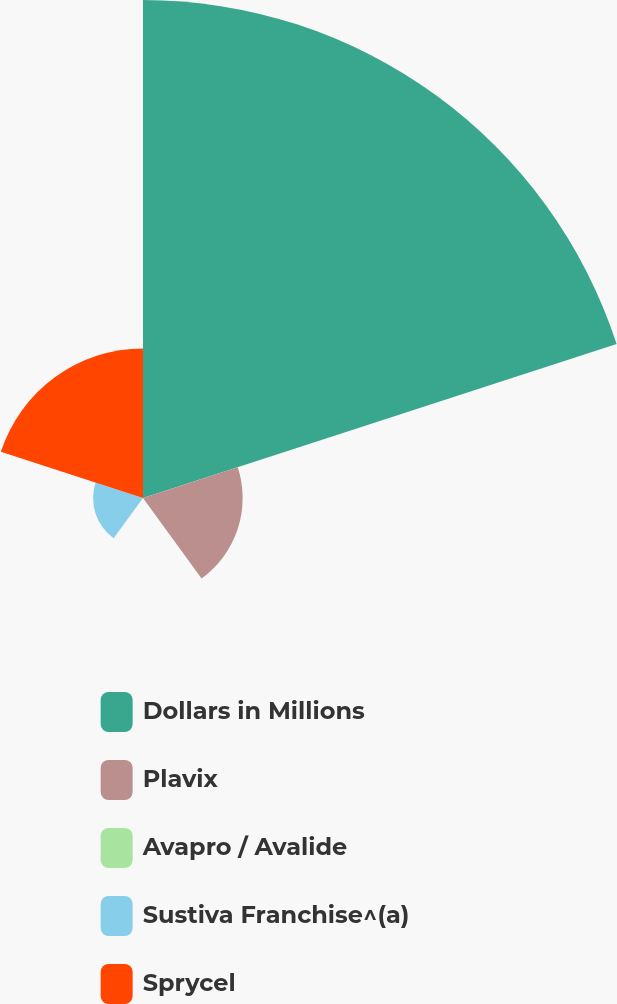<chart> <loc_0><loc_0><loc_500><loc_500><pie_chart><fcel>Dollars in Millions<fcel>Plavix<fcel>Avapro / Avalide<fcel>Sustiva Franchise^(a)<fcel>Sprycel<nl><fcel>62.47%<fcel>12.5%<fcel>0.01%<fcel>6.26%<fcel>18.75%<nl></chart> 